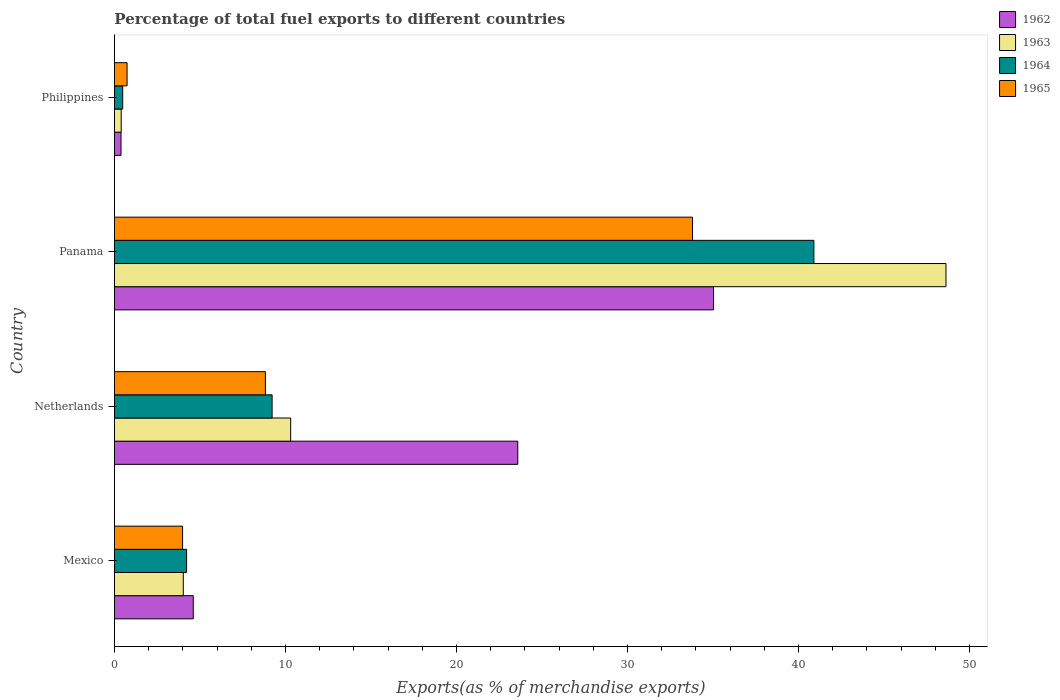Are the number of bars per tick equal to the number of legend labels?
Provide a succinct answer. Yes. How many bars are there on the 1st tick from the top?
Offer a terse response. 4. How many bars are there on the 2nd tick from the bottom?
Ensure brevity in your answer.  4. What is the percentage of exports to different countries in 1963 in Mexico?
Keep it short and to the point. 4.03. Across all countries, what is the maximum percentage of exports to different countries in 1965?
Your answer should be very brief. 33.8. Across all countries, what is the minimum percentage of exports to different countries in 1962?
Offer a terse response. 0.38. In which country was the percentage of exports to different countries in 1964 maximum?
Your response must be concise. Panama. What is the total percentage of exports to different countries in 1963 in the graph?
Provide a succinct answer. 63.35. What is the difference between the percentage of exports to different countries in 1962 in Mexico and that in Netherlands?
Offer a terse response. -18.97. What is the difference between the percentage of exports to different countries in 1965 in Panama and the percentage of exports to different countries in 1963 in Philippines?
Make the answer very short. 33.41. What is the average percentage of exports to different countries in 1963 per country?
Keep it short and to the point. 15.84. What is the difference between the percentage of exports to different countries in 1964 and percentage of exports to different countries in 1962 in Philippines?
Keep it short and to the point. 0.1. In how many countries, is the percentage of exports to different countries in 1964 greater than 2 %?
Ensure brevity in your answer.  3. What is the ratio of the percentage of exports to different countries in 1965 in Netherlands to that in Panama?
Offer a very short reply. 0.26. Is the difference between the percentage of exports to different countries in 1964 in Netherlands and Philippines greater than the difference between the percentage of exports to different countries in 1962 in Netherlands and Philippines?
Make the answer very short. No. What is the difference between the highest and the second highest percentage of exports to different countries in 1965?
Offer a very short reply. 24.98. What is the difference between the highest and the lowest percentage of exports to different countries in 1965?
Provide a short and direct response. 33.06. What does the 4th bar from the bottom in Netherlands represents?
Give a very brief answer. 1965. Is it the case that in every country, the sum of the percentage of exports to different countries in 1963 and percentage of exports to different countries in 1964 is greater than the percentage of exports to different countries in 1965?
Your response must be concise. Yes. How many bars are there?
Give a very brief answer. 16. Does the graph contain any zero values?
Offer a terse response. No. How many legend labels are there?
Ensure brevity in your answer.  4. How are the legend labels stacked?
Provide a succinct answer. Vertical. What is the title of the graph?
Keep it short and to the point. Percentage of total fuel exports to different countries. What is the label or title of the X-axis?
Make the answer very short. Exports(as % of merchandise exports). What is the label or title of the Y-axis?
Provide a short and direct response. Country. What is the Exports(as % of merchandise exports) in 1962 in Mexico?
Offer a very short reply. 4.61. What is the Exports(as % of merchandise exports) of 1963 in Mexico?
Your answer should be compact. 4.03. What is the Exports(as % of merchandise exports) of 1964 in Mexico?
Provide a short and direct response. 4.22. What is the Exports(as % of merchandise exports) in 1965 in Mexico?
Give a very brief answer. 3.99. What is the Exports(as % of merchandise exports) in 1962 in Netherlands?
Give a very brief answer. 23.58. What is the Exports(as % of merchandise exports) in 1963 in Netherlands?
Offer a terse response. 10.31. What is the Exports(as % of merchandise exports) in 1964 in Netherlands?
Keep it short and to the point. 9.22. What is the Exports(as % of merchandise exports) of 1965 in Netherlands?
Your answer should be very brief. 8.83. What is the Exports(as % of merchandise exports) in 1962 in Panama?
Keep it short and to the point. 35.03. What is the Exports(as % of merchandise exports) of 1963 in Panama?
Offer a terse response. 48.62. What is the Exports(as % of merchandise exports) in 1964 in Panama?
Your response must be concise. 40.9. What is the Exports(as % of merchandise exports) of 1965 in Panama?
Provide a short and direct response. 33.8. What is the Exports(as % of merchandise exports) in 1962 in Philippines?
Make the answer very short. 0.38. What is the Exports(as % of merchandise exports) of 1963 in Philippines?
Give a very brief answer. 0.4. What is the Exports(as % of merchandise exports) of 1964 in Philippines?
Offer a terse response. 0.48. What is the Exports(as % of merchandise exports) of 1965 in Philippines?
Give a very brief answer. 0.74. Across all countries, what is the maximum Exports(as % of merchandise exports) in 1962?
Your answer should be compact. 35.03. Across all countries, what is the maximum Exports(as % of merchandise exports) of 1963?
Your answer should be very brief. 48.62. Across all countries, what is the maximum Exports(as % of merchandise exports) of 1964?
Keep it short and to the point. 40.9. Across all countries, what is the maximum Exports(as % of merchandise exports) of 1965?
Give a very brief answer. 33.8. Across all countries, what is the minimum Exports(as % of merchandise exports) of 1962?
Ensure brevity in your answer.  0.38. Across all countries, what is the minimum Exports(as % of merchandise exports) of 1963?
Offer a terse response. 0.4. Across all countries, what is the minimum Exports(as % of merchandise exports) of 1964?
Offer a very short reply. 0.48. Across all countries, what is the minimum Exports(as % of merchandise exports) in 1965?
Your answer should be very brief. 0.74. What is the total Exports(as % of merchandise exports) of 1962 in the graph?
Give a very brief answer. 63.61. What is the total Exports(as % of merchandise exports) of 1963 in the graph?
Provide a succinct answer. 63.35. What is the total Exports(as % of merchandise exports) of 1964 in the graph?
Offer a very short reply. 54.82. What is the total Exports(as % of merchandise exports) in 1965 in the graph?
Your answer should be very brief. 47.35. What is the difference between the Exports(as % of merchandise exports) of 1962 in Mexico and that in Netherlands?
Your answer should be compact. -18.97. What is the difference between the Exports(as % of merchandise exports) in 1963 in Mexico and that in Netherlands?
Keep it short and to the point. -6.28. What is the difference between the Exports(as % of merchandise exports) of 1964 in Mexico and that in Netherlands?
Ensure brevity in your answer.  -5. What is the difference between the Exports(as % of merchandise exports) of 1965 in Mexico and that in Netherlands?
Keep it short and to the point. -4.84. What is the difference between the Exports(as % of merchandise exports) in 1962 in Mexico and that in Panama?
Your answer should be compact. -30.42. What is the difference between the Exports(as % of merchandise exports) of 1963 in Mexico and that in Panama?
Give a very brief answer. -44.59. What is the difference between the Exports(as % of merchandise exports) in 1964 in Mexico and that in Panama?
Your answer should be very brief. -36.68. What is the difference between the Exports(as % of merchandise exports) of 1965 in Mexico and that in Panama?
Offer a very short reply. -29.82. What is the difference between the Exports(as % of merchandise exports) in 1962 in Mexico and that in Philippines?
Offer a terse response. 4.22. What is the difference between the Exports(as % of merchandise exports) in 1963 in Mexico and that in Philippines?
Offer a terse response. 3.63. What is the difference between the Exports(as % of merchandise exports) in 1964 in Mexico and that in Philippines?
Make the answer very short. 3.74. What is the difference between the Exports(as % of merchandise exports) in 1965 in Mexico and that in Philippines?
Your response must be concise. 3.25. What is the difference between the Exports(as % of merchandise exports) of 1962 in Netherlands and that in Panama?
Provide a succinct answer. -11.45. What is the difference between the Exports(as % of merchandise exports) of 1963 in Netherlands and that in Panama?
Ensure brevity in your answer.  -38.32. What is the difference between the Exports(as % of merchandise exports) in 1964 in Netherlands and that in Panama?
Your answer should be compact. -31.68. What is the difference between the Exports(as % of merchandise exports) in 1965 in Netherlands and that in Panama?
Give a very brief answer. -24.98. What is the difference between the Exports(as % of merchandise exports) in 1962 in Netherlands and that in Philippines?
Give a very brief answer. 23.2. What is the difference between the Exports(as % of merchandise exports) in 1963 in Netherlands and that in Philippines?
Offer a very short reply. 9.91. What is the difference between the Exports(as % of merchandise exports) of 1964 in Netherlands and that in Philippines?
Provide a short and direct response. 8.74. What is the difference between the Exports(as % of merchandise exports) of 1965 in Netherlands and that in Philippines?
Make the answer very short. 8.09. What is the difference between the Exports(as % of merchandise exports) in 1962 in Panama and that in Philippines?
Your answer should be compact. 34.65. What is the difference between the Exports(as % of merchandise exports) of 1963 in Panama and that in Philippines?
Ensure brevity in your answer.  48.22. What is the difference between the Exports(as % of merchandise exports) in 1964 in Panama and that in Philippines?
Ensure brevity in your answer.  40.41. What is the difference between the Exports(as % of merchandise exports) in 1965 in Panama and that in Philippines?
Your answer should be very brief. 33.06. What is the difference between the Exports(as % of merchandise exports) in 1962 in Mexico and the Exports(as % of merchandise exports) in 1963 in Netherlands?
Give a very brief answer. -5.7. What is the difference between the Exports(as % of merchandise exports) in 1962 in Mexico and the Exports(as % of merchandise exports) in 1964 in Netherlands?
Your answer should be very brief. -4.61. What is the difference between the Exports(as % of merchandise exports) of 1962 in Mexico and the Exports(as % of merchandise exports) of 1965 in Netherlands?
Provide a short and direct response. -4.22. What is the difference between the Exports(as % of merchandise exports) of 1963 in Mexico and the Exports(as % of merchandise exports) of 1964 in Netherlands?
Your answer should be very brief. -5.19. What is the difference between the Exports(as % of merchandise exports) of 1963 in Mexico and the Exports(as % of merchandise exports) of 1965 in Netherlands?
Provide a short and direct response. -4.8. What is the difference between the Exports(as % of merchandise exports) in 1964 in Mexico and the Exports(as % of merchandise exports) in 1965 in Netherlands?
Give a very brief answer. -4.61. What is the difference between the Exports(as % of merchandise exports) of 1962 in Mexico and the Exports(as % of merchandise exports) of 1963 in Panama?
Provide a short and direct response. -44.01. What is the difference between the Exports(as % of merchandise exports) of 1962 in Mexico and the Exports(as % of merchandise exports) of 1964 in Panama?
Give a very brief answer. -36.29. What is the difference between the Exports(as % of merchandise exports) in 1962 in Mexico and the Exports(as % of merchandise exports) in 1965 in Panama?
Offer a terse response. -29.19. What is the difference between the Exports(as % of merchandise exports) in 1963 in Mexico and the Exports(as % of merchandise exports) in 1964 in Panama?
Give a very brief answer. -36.87. What is the difference between the Exports(as % of merchandise exports) in 1963 in Mexico and the Exports(as % of merchandise exports) in 1965 in Panama?
Give a very brief answer. -29.78. What is the difference between the Exports(as % of merchandise exports) of 1964 in Mexico and the Exports(as % of merchandise exports) of 1965 in Panama?
Make the answer very short. -29.58. What is the difference between the Exports(as % of merchandise exports) in 1962 in Mexico and the Exports(as % of merchandise exports) in 1963 in Philippines?
Keep it short and to the point. 4.21. What is the difference between the Exports(as % of merchandise exports) of 1962 in Mexico and the Exports(as % of merchandise exports) of 1964 in Philippines?
Provide a succinct answer. 4.13. What is the difference between the Exports(as % of merchandise exports) in 1962 in Mexico and the Exports(as % of merchandise exports) in 1965 in Philippines?
Your answer should be very brief. 3.87. What is the difference between the Exports(as % of merchandise exports) in 1963 in Mexico and the Exports(as % of merchandise exports) in 1964 in Philippines?
Offer a terse response. 3.54. What is the difference between the Exports(as % of merchandise exports) in 1963 in Mexico and the Exports(as % of merchandise exports) in 1965 in Philippines?
Give a very brief answer. 3.29. What is the difference between the Exports(as % of merchandise exports) in 1964 in Mexico and the Exports(as % of merchandise exports) in 1965 in Philippines?
Offer a terse response. 3.48. What is the difference between the Exports(as % of merchandise exports) of 1962 in Netherlands and the Exports(as % of merchandise exports) of 1963 in Panama?
Keep it short and to the point. -25.04. What is the difference between the Exports(as % of merchandise exports) in 1962 in Netherlands and the Exports(as % of merchandise exports) in 1964 in Panama?
Offer a very short reply. -17.31. What is the difference between the Exports(as % of merchandise exports) of 1962 in Netherlands and the Exports(as % of merchandise exports) of 1965 in Panama?
Offer a terse response. -10.22. What is the difference between the Exports(as % of merchandise exports) in 1963 in Netherlands and the Exports(as % of merchandise exports) in 1964 in Panama?
Offer a very short reply. -30.59. What is the difference between the Exports(as % of merchandise exports) of 1963 in Netherlands and the Exports(as % of merchandise exports) of 1965 in Panama?
Offer a terse response. -23.5. What is the difference between the Exports(as % of merchandise exports) of 1964 in Netherlands and the Exports(as % of merchandise exports) of 1965 in Panama?
Give a very brief answer. -24.58. What is the difference between the Exports(as % of merchandise exports) of 1962 in Netherlands and the Exports(as % of merchandise exports) of 1963 in Philippines?
Your answer should be compact. 23.19. What is the difference between the Exports(as % of merchandise exports) of 1962 in Netherlands and the Exports(as % of merchandise exports) of 1964 in Philippines?
Ensure brevity in your answer.  23.1. What is the difference between the Exports(as % of merchandise exports) in 1962 in Netherlands and the Exports(as % of merchandise exports) in 1965 in Philippines?
Keep it short and to the point. 22.84. What is the difference between the Exports(as % of merchandise exports) of 1963 in Netherlands and the Exports(as % of merchandise exports) of 1964 in Philippines?
Your answer should be very brief. 9.82. What is the difference between the Exports(as % of merchandise exports) of 1963 in Netherlands and the Exports(as % of merchandise exports) of 1965 in Philippines?
Make the answer very short. 9.57. What is the difference between the Exports(as % of merchandise exports) of 1964 in Netherlands and the Exports(as % of merchandise exports) of 1965 in Philippines?
Keep it short and to the point. 8.48. What is the difference between the Exports(as % of merchandise exports) in 1962 in Panama and the Exports(as % of merchandise exports) in 1963 in Philippines?
Offer a terse response. 34.63. What is the difference between the Exports(as % of merchandise exports) of 1962 in Panama and the Exports(as % of merchandise exports) of 1964 in Philippines?
Give a very brief answer. 34.55. What is the difference between the Exports(as % of merchandise exports) of 1962 in Panama and the Exports(as % of merchandise exports) of 1965 in Philippines?
Offer a very short reply. 34.29. What is the difference between the Exports(as % of merchandise exports) in 1963 in Panama and the Exports(as % of merchandise exports) in 1964 in Philippines?
Your answer should be very brief. 48.14. What is the difference between the Exports(as % of merchandise exports) in 1963 in Panama and the Exports(as % of merchandise exports) in 1965 in Philippines?
Provide a short and direct response. 47.88. What is the difference between the Exports(as % of merchandise exports) in 1964 in Panama and the Exports(as % of merchandise exports) in 1965 in Philippines?
Provide a succinct answer. 40.16. What is the average Exports(as % of merchandise exports) of 1962 per country?
Ensure brevity in your answer.  15.9. What is the average Exports(as % of merchandise exports) in 1963 per country?
Give a very brief answer. 15.84. What is the average Exports(as % of merchandise exports) in 1964 per country?
Ensure brevity in your answer.  13.71. What is the average Exports(as % of merchandise exports) of 1965 per country?
Your answer should be very brief. 11.84. What is the difference between the Exports(as % of merchandise exports) in 1962 and Exports(as % of merchandise exports) in 1963 in Mexico?
Give a very brief answer. 0.58. What is the difference between the Exports(as % of merchandise exports) of 1962 and Exports(as % of merchandise exports) of 1964 in Mexico?
Ensure brevity in your answer.  0.39. What is the difference between the Exports(as % of merchandise exports) in 1962 and Exports(as % of merchandise exports) in 1965 in Mexico?
Give a very brief answer. 0.62. What is the difference between the Exports(as % of merchandise exports) in 1963 and Exports(as % of merchandise exports) in 1964 in Mexico?
Provide a succinct answer. -0.19. What is the difference between the Exports(as % of merchandise exports) in 1963 and Exports(as % of merchandise exports) in 1965 in Mexico?
Your answer should be compact. 0.04. What is the difference between the Exports(as % of merchandise exports) of 1964 and Exports(as % of merchandise exports) of 1965 in Mexico?
Offer a terse response. 0.23. What is the difference between the Exports(as % of merchandise exports) of 1962 and Exports(as % of merchandise exports) of 1963 in Netherlands?
Your response must be concise. 13.28. What is the difference between the Exports(as % of merchandise exports) of 1962 and Exports(as % of merchandise exports) of 1964 in Netherlands?
Ensure brevity in your answer.  14.36. What is the difference between the Exports(as % of merchandise exports) in 1962 and Exports(as % of merchandise exports) in 1965 in Netherlands?
Provide a short and direct response. 14.76. What is the difference between the Exports(as % of merchandise exports) in 1963 and Exports(as % of merchandise exports) in 1964 in Netherlands?
Provide a short and direct response. 1.09. What is the difference between the Exports(as % of merchandise exports) of 1963 and Exports(as % of merchandise exports) of 1965 in Netherlands?
Your answer should be compact. 1.48. What is the difference between the Exports(as % of merchandise exports) in 1964 and Exports(as % of merchandise exports) in 1965 in Netherlands?
Offer a terse response. 0.39. What is the difference between the Exports(as % of merchandise exports) of 1962 and Exports(as % of merchandise exports) of 1963 in Panama?
Give a very brief answer. -13.59. What is the difference between the Exports(as % of merchandise exports) of 1962 and Exports(as % of merchandise exports) of 1964 in Panama?
Your answer should be very brief. -5.87. What is the difference between the Exports(as % of merchandise exports) of 1962 and Exports(as % of merchandise exports) of 1965 in Panama?
Your response must be concise. 1.23. What is the difference between the Exports(as % of merchandise exports) in 1963 and Exports(as % of merchandise exports) in 1964 in Panama?
Ensure brevity in your answer.  7.72. What is the difference between the Exports(as % of merchandise exports) of 1963 and Exports(as % of merchandise exports) of 1965 in Panama?
Your response must be concise. 14.82. What is the difference between the Exports(as % of merchandise exports) of 1964 and Exports(as % of merchandise exports) of 1965 in Panama?
Offer a terse response. 7.1. What is the difference between the Exports(as % of merchandise exports) in 1962 and Exports(as % of merchandise exports) in 1963 in Philippines?
Give a very brief answer. -0.01. What is the difference between the Exports(as % of merchandise exports) of 1962 and Exports(as % of merchandise exports) of 1964 in Philippines?
Provide a succinct answer. -0.1. What is the difference between the Exports(as % of merchandise exports) of 1962 and Exports(as % of merchandise exports) of 1965 in Philippines?
Offer a very short reply. -0.35. What is the difference between the Exports(as % of merchandise exports) in 1963 and Exports(as % of merchandise exports) in 1964 in Philippines?
Your answer should be very brief. -0.09. What is the difference between the Exports(as % of merchandise exports) in 1963 and Exports(as % of merchandise exports) in 1965 in Philippines?
Your answer should be very brief. -0.34. What is the difference between the Exports(as % of merchandise exports) in 1964 and Exports(as % of merchandise exports) in 1965 in Philippines?
Provide a short and direct response. -0.26. What is the ratio of the Exports(as % of merchandise exports) of 1962 in Mexico to that in Netherlands?
Provide a short and direct response. 0.2. What is the ratio of the Exports(as % of merchandise exports) of 1963 in Mexico to that in Netherlands?
Offer a very short reply. 0.39. What is the ratio of the Exports(as % of merchandise exports) of 1964 in Mexico to that in Netherlands?
Your answer should be very brief. 0.46. What is the ratio of the Exports(as % of merchandise exports) in 1965 in Mexico to that in Netherlands?
Offer a terse response. 0.45. What is the ratio of the Exports(as % of merchandise exports) in 1962 in Mexico to that in Panama?
Offer a very short reply. 0.13. What is the ratio of the Exports(as % of merchandise exports) of 1963 in Mexico to that in Panama?
Your response must be concise. 0.08. What is the ratio of the Exports(as % of merchandise exports) of 1964 in Mexico to that in Panama?
Make the answer very short. 0.1. What is the ratio of the Exports(as % of merchandise exports) of 1965 in Mexico to that in Panama?
Your response must be concise. 0.12. What is the ratio of the Exports(as % of merchandise exports) in 1962 in Mexico to that in Philippines?
Offer a very short reply. 11.97. What is the ratio of the Exports(as % of merchandise exports) in 1963 in Mexico to that in Philippines?
Ensure brevity in your answer.  10.17. What is the ratio of the Exports(as % of merchandise exports) of 1964 in Mexico to that in Philippines?
Ensure brevity in your answer.  8.73. What is the ratio of the Exports(as % of merchandise exports) in 1965 in Mexico to that in Philippines?
Ensure brevity in your answer.  5.39. What is the ratio of the Exports(as % of merchandise exports) in 1962 in Netherlands to that in Panama?
Give a very brief answer. 0.67. What is the ratio of the Exports(as % of merchandise exports) of 1963 in Netherlands to that in Panama?
Provide a short and direct response. 0.21. What is the ratio of the Exports(as % of merchandise exports) in 1964 in Netherlands to that in Panama?
Offer a terse response. 0.23. What is the ratio of the Exports(as % of merchandise exports) of 1965 in Netherlands to that in Panama?
Ensure brevity in your answer.  0.26. What is the ratio of the Exports(as % of merchandise exports) in 1962 in Netherlands to that in Philippines?
Provide a succinct answer. 61.27. What is the ratio of the Exports(as % of merchandise exports) in 1963 in Netherlands to that in Philippines?
Offer a very short reply. 26.03. What is the ratio of the Exports(as % of merchandise exports) in 1964 in Netherlands to that in Philippines?
Keep it short and to the point. 19.07. What is the ratio of the Exports(as % of merchandise exports) of 1965 in Netherlands to that in Philippines?
Keep it short and to the point. 11.93. What is the ratio of the Exports(as % of merchandise exports) of 1962 in Panama to that in Philippines?
Your response must be concise. 91.01. What is the ratio of the Exports(as % of merchandise exports) in 1963 in Panama to that in Philippines?
Your answer should be compact. 122.82. What is the ratio of the Exports(as % of merchandise exports) of 1964 in Panama to that in Philippines?
Your response must be concise. 84.6. What is the ratio of the Exports(as % of merchandise exports) in 1965 in Panama to that in Philippines?
Give a very brief answer. 45.69. What is the difference between the highest and the second highest Exports(as % of merchandise exports) of 1962?
Your response must be concise. 11.45. What is the difference between the highest and the second highest Exports(as % of merchandise exports) in 1963?
Offer a terse response. 38.32. What is the difference between the highest and the second highest Exports(as % of merchandise exports) of 1964?
Offer a very short reply. 31.68. What is the difference between the highest and the second highest Exports(as % of merchandise exports) of 1965?
Keep it short and to the point. 24.98. What is the difference between the highest and the lowest Exports(as % of merchandise exports) in 1962?
Offer a terse response. 34.65. What is the difference between the highest and the lowest Exports(as % of merchandise exports) of 1963?
Keep it short and to the point. 48.22. What is the difference between the highest and the lowest Exports(as % of merchandise exports) of 1964?
Your answer should be compact. 40.41. What is the difference between the highest and the lowest Exports(as % of merchandise exports) in 1965?
Make the answer very short. 33.06. 